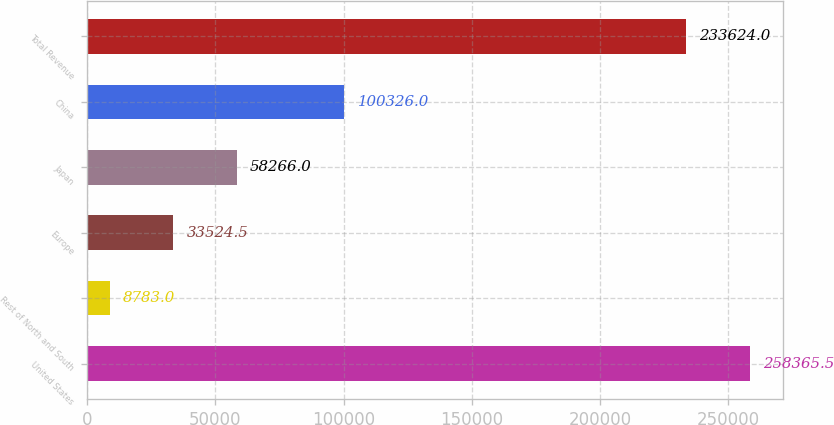Convert chart to OTSL. <chart><loc_0><loc_0><loc_500><loc_500><bar_chart><fcel>United States<fcel>Rest of North and South<fcel>Europe<fcel>Japan<fcel>China<fcel>Total Revenue<nl><fcel>258366<fcel>8783<fcel>33524.5<fcel>58266<fcel>100326<fcel>233624<nl></chart> 